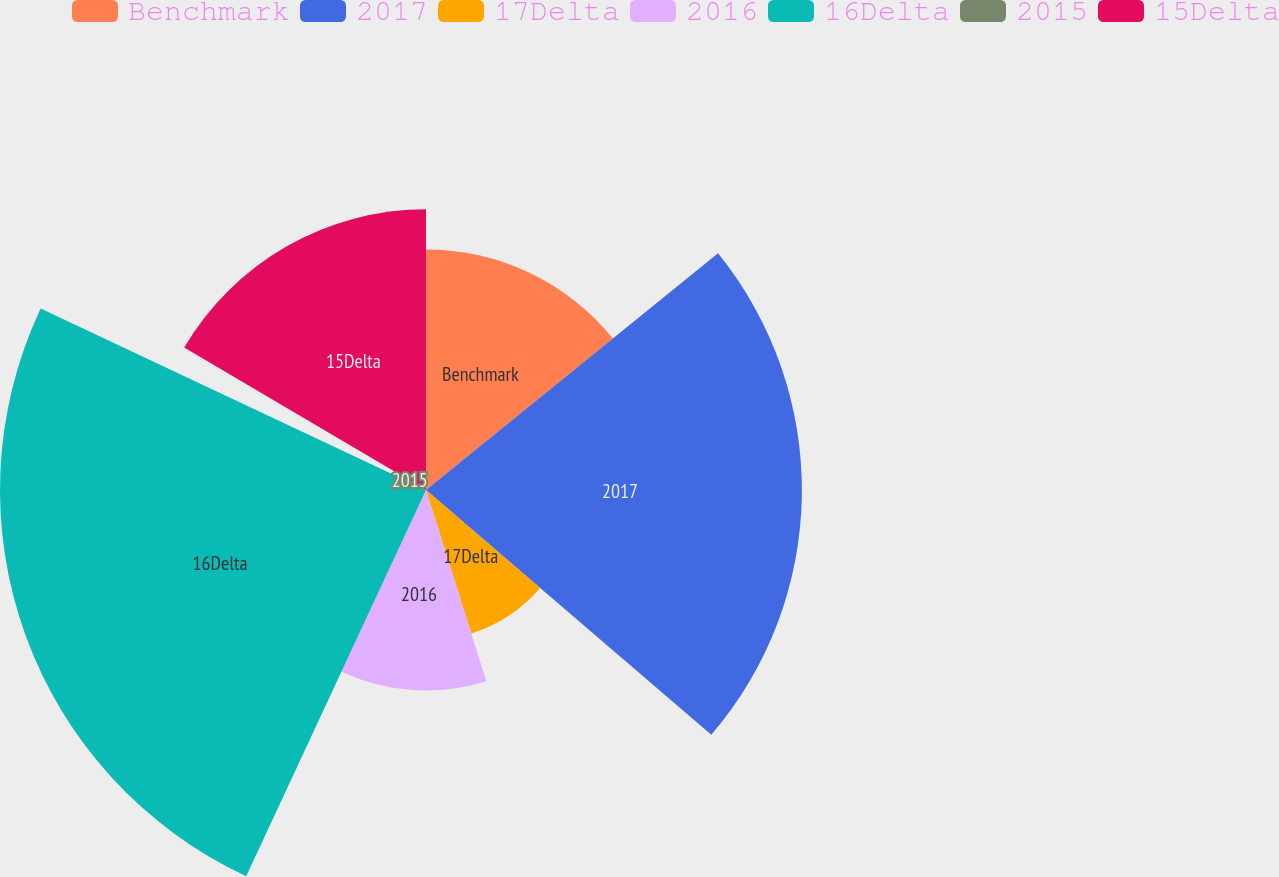Convert chart. <chart><loc_0><loc_0><loc_500><loc_500><pie_chart><fcel>Benchmark<fcel>2017<fcel>17Delta<fcel>2016<fcel>16Delta<fcel>2015<fcel>15Delta<nl><fcel>14.16%<fcel>22.12%<fcel>8.85%<fcel>11.8%<fcel>25.07%<fcel>1.47%<fcel>16.52%<nl></chart> 